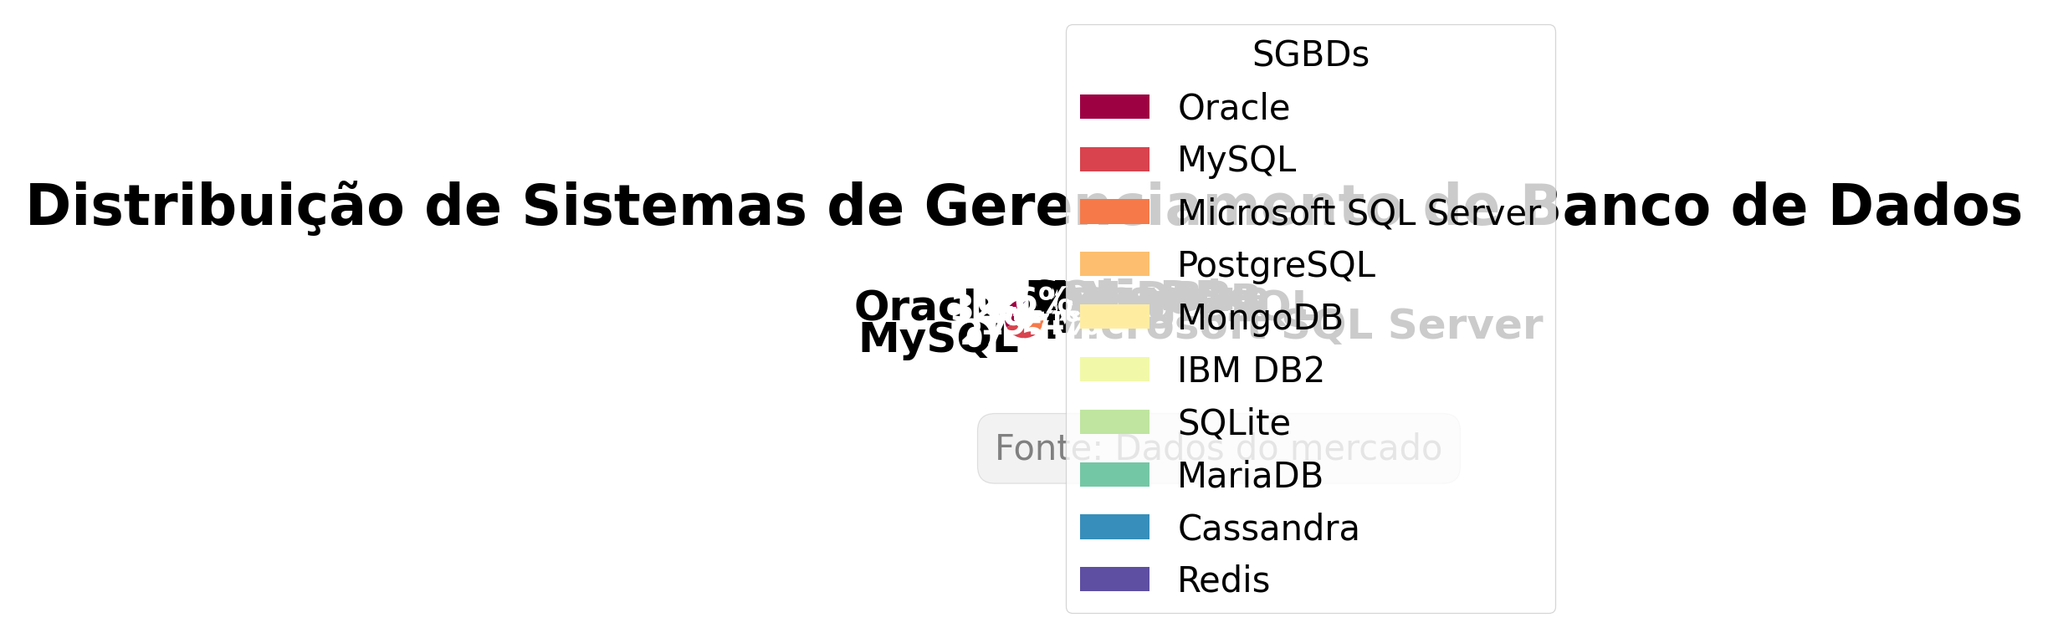Qual é o Sistema de Gerenciamento de Banco de Dados com maior participação de mercado? Observando o gráfico, o maior segmento do gráfico de pizza é rotulado como "Oracle" com 32.5%. Logo, Oracle é o que tem a maior participação.
Answer: Oracle Qual é o Sistema de Gerenciamento de Banco de Dados com a menor participação de mercado? O menor segmento do gráfico de pizza é rotulado como "Redis" com 0.6%. Logo, Redis tem a menor participação.
Answer: Redis Qual a participação combinada dos três principais Sistemas de Gerenciamento de Banco de Dados? Somando os valores das três maiores participações: Oracle (32.5%), MySQL (27.8%) e Microsoft SQL Server (19.6%), temos 32.5 + 27.8 + 19.6 = 79.9%.
Answer: 79.9% Qual é a diferença na participação de mercado entre Oracle e MySQL? A participação de mercado do Oracle é 32.5% e do MySQL é 27.8%. A diferença é 32.5 - 27.8 = 4.7%.
Answer: 4.7% Quais SGBDs têm participação de mercado inferior a 5%? Observando o gráfico, os segmentos com participação inferior a 5% são: MongoDB (4.2%), IBM DB2 (3.1%), SQLite (2.5%), MariaDB (1.2%), Cassandra (0.8%) e Redis (0.6%).
Answer: MongoDB, IBM DB2, SQLite, MariaDB, Cassandra, Redis Qual SGBD tem uma participação de mercado mais próxima de 10%? O segmento mais próximo de 10% é o PostgreSQL com 8.7%.
Answer: PostgreSQL Qual é a participação total dos SGBDs com mais de 20% de mercado? Somando os valores das participações de Oracle (32.5%) e MySQL (27.8%) que são maiores que 20%, temos 32.5 + 27.8 = 60.3%.
Answer: 60.3% Quais SGBDs têm uma participação de mercado combinada de aproximadamente 10%? Somando os valores de MongoDB (4.2%), IBM DB2 (3.1%), e SQLite (2.5%), temos 4.2 + 3.1 + 2.5 = 9.8%, que é próximo de 10%.
Answer: MongoDB, IBM DB2, SQLite 